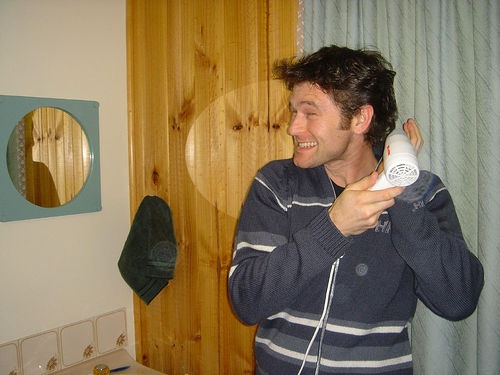Describe the objects in this image and their specific colors. I can see people in darkgray, black, gray, and tan tones and hair drier in darkgray, lightgray, and tan tones in this image. 